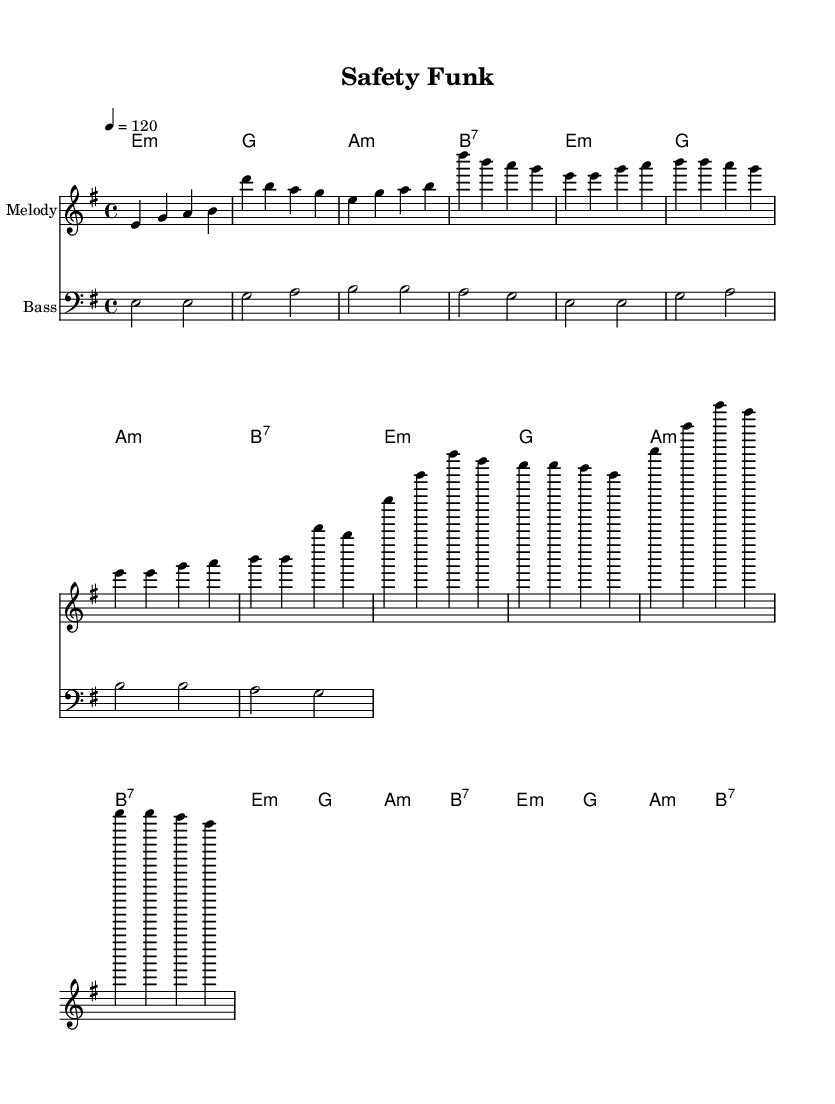What is the key signature of this music? The key signature shows that the piece is in E minor, which has one sharp (F#). This can be determined by observing the key signature marking next to the clef in the sheet music.
Answer: E minor What is the time signature of this music? The time signature is indicated at the beginning of the score, which shows the music has a 4/4 time signature. This means there are four beats in each measure with a quarter note receiving one beat.
Answer: 4/4 What is the tempo marking for this piece? The tempo marking is indicated in the score as "4 = 120". This shows that a quarter note equals 120 beats per minute, meaning the music is played fairly briskly.
Answer: 120 How many measures are in the verse section? Counting the measures in the stated verse lyrics reveals that there are 8 measures in total. Each phrase in the verse corresponds to specific measures laid out in the melody.
Answer: 8 measures What are the four main protective equipment items mentioned in the lyrics? The lyrics specifically mention "hard hat," "steel-toed shoes," "safety glasses," and "gear." Identifying these items can be done by referring directly to the lyric lines in the score that enumerate safety gear.
Answer: hard hat, steel-toed shoes, safety glasses, gear What is the repeated phrase at the beginning of the chorus? The chorus begins with the repeated phrase "Safety Funk," which occurs twice in succession. This can be observed by looking at the chorus lyrics specifically for repeated phrases.
Answer: Safety Funk What is the overall mood of the song, based on its tempo and style? The song's upbeat tempo of 120 BPM combined with the funky rhythms and catchy lyrics promotes a lively and energetic mood. This can be deduced from the tempo marking and the engaging nature of the funk genre typical characteristics.
Answer: Lively and energetic 